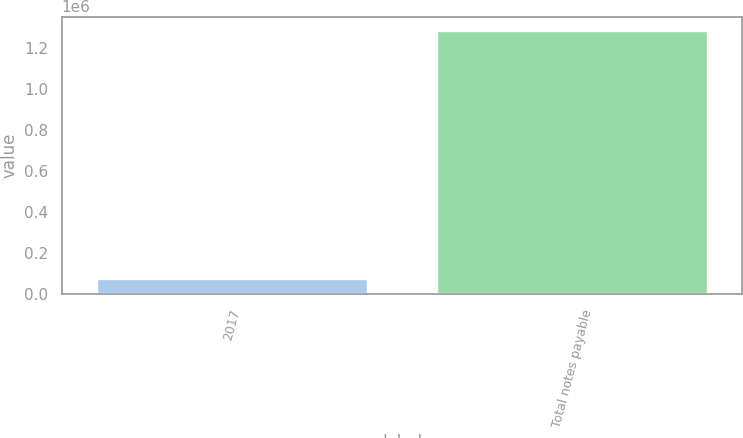Convert chart to OTSL. <chart><loc_0><loc_0><loc_500><loc_500><bar_chart><fcel>2017<fcel>Total notes payable<nl><fcel>77385<fcel>1.28663e+06<nl></chart> 